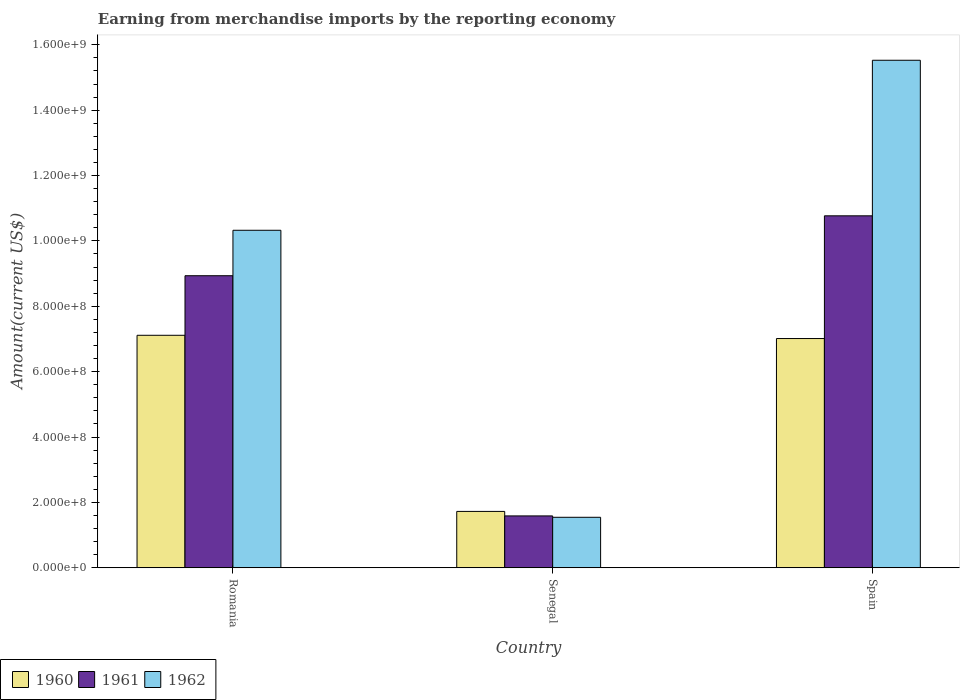How many bars are there on the 3rd tick from the left?
Your answer should be compact. 3. What is the label of the 2nd group of bars from the left?
Ensure brevity in your answer.  Senegal. In how many cases, is the number of bars for a given country not equal to the number of legend labels?
Provide a short and direct response. 0. What is the amount earned from merchandise imports in 1960 in Romania?
Your answer should be very brief. 7.11e+08. Across all countries, what is the maximum amount earned from merchandise imports in 1962?
Your answer should be compact. 1.55e+09. Across all countries, what is the minimum amount earned from merchandise imports in 1962?
Ensure brevity in your answer.  1.54e+08. In which country was the amount earned from merchandise imports in 1961 minimum?
Keep it short and to the point. Senegal. What is the total amount earned from merchandise imports in 1962 in the graph?
Provide a succinct answer. 2.74e+09. What is the difference between the amount earned from merchandise imports in 1962 in Romania and that in Spain?
Ensure brevity in your answer.  -5.20e+08. What is the difference between the amount earned from merchandise imports in 1962 in Senegal and the amount earned from merchandise imports in 1960 in Spain?
Your response must be concise. -5.47e+08. What is the average amount earned from merchandise imports in 1961 per country?
Offer a very short reply. 7.10e+08. What is the difference between the amount earned from merchandise imports of/in 1962 and amount earned from merchandise imports of/in 1960 in Spain?
Keep it short and to the point. 8.52e+08. What is the ratio of the amount earned from merchandise imports in 1960 in Senegal to that in Spain?
Make the answer very short. 0.25. Is the amount earned from merchandise imports in 1962 in Romania less than that in Spain?
Give a very brief answer. Yes. Is the difference between the amount earned from merchandise imports in 1962 in Senegal and Spain greater than the difference between the amount earned from merchandise imports in 1960 in Senegal and Spain?
Offer a terse response. No. What is the difference between the highest and the second highest amount earned from merchandise imports in 1962?
Your answer should be very brief. 1.40e+09. What is the difference between the highest and the lowest amount earned from merchandise imports in 1961?
Your answer should be compact. 9.18e+08. Is the sum of the amount earned from merchandise imports in 1961 in Senegal and Spain greater than the maximum amount earned from merchandise imports in 1960 across all countries?
Provide a succinct answer. Yes. What does the 1st bar from the left in Senegal represents?
Ensure brevity in your answer.  1960. Is it the case that in every country, the sum of the amount earned from merchandise imports in 1960 and amount earned from merchandise imports in 1962 is greater than the amount earned from merchandise imports in 1961?
Make the answer very short. Yes. How many bars are there?
Your response must be concise. 9. Are the values on the major ticks of Y-axis written in scientific E-notation?
Keep it short and to the point. Yes. Does the graph contain any zero values?
Your response must be concise. No. Where does the legend appear in the graph?
Your answer should be compact. Bottom left. How many legend labels are there?
Your answer should be compact. 3. How are the legend labels stacked?
Give a very brief answer. Horizontal. What is the title of the graph?
Offer a terse response. Earning from merchandise imports by the reporting economy. What is the label or title of the Y-axis?
Give a very brief answer. Amount(current US$). What is the Amount(current US$) of 1960 in Romania?
Provide a short and direct response. 7.11e+08. What is the Amount(current US$) in 1961 in Romania?
Offer a very short reply. 8.94e+08. What is the Amount(current US$) of 1962 in Romania?
Offer a terse response. 1.03e+09. What is the Amount(current US$) in 1960 in Senegal?
Your answer should be very brief. 1.72e+08. What is the Amount(current US$) of 1961 in Senegal?
Give a very brief answer. 1.59e+08. What is the Amount(current US$) in 1962 in Senegal?
Keep it short and to the point. 1.54e+08. What is the Amount(current US$) in 1960 in Spain?
Your answer should be compact. 7.01e+08. What is the Amount(current US$) of 1961 in Spain?
Make the answer very short. 1.08e+09. What is the Amount(current US$) in 1962 in Spain?
Offer a very short reply. 1.55e+09. Across all countries, what is the maximum Amount(current US$) of 1960?
Provide a succinct answer. 7.11e+08. Across all countries, what is the maximum Amount(current US$) of 1961?
Offer a very short reply. 1.08e+09. Across all countries, what is the maximum Amount(current US$) in 1962?
Keep it short and to the point. 1.55e+09. Across all countries, what is the minimum Amount(current US$) of 1960?
Keep it short and to the point. 1.72e+08. Across all countries, what is the minimum Amount(current US$) in 1961?
Keep it short and to the point. 1.59e+08. Across all countries, what is the minimum Amount(current US$) in 1962?
Give a very brief answer. 1.54e+08. What is the total Amount(current US$) in 1960 in the graph?
Your answer should be very brief. 1.58e+09. What is the total Amount(current US$) in 1961 in the graph?
Keep it short and to the point. 2.13e+09. What is the total Amount(current US$) of 1962 in the graph?
Keep it short and to the point. 2.74e+09. What is the difference between the Amount(current US$) of 1960 in Romania and that in Senegal?
Keep it short and to the point. 5.39e+08. What is the difference between the Amount(current US$) in 1961 in Romania and that in Senegal?
Make the answer very short. 7.35e+08. What is the difference between the Amount(current US$) in 1962 in Romania and that in Senegal?
Make the answer very short. 8.78e+08. What is the difference between the Amount(current US$) of 1960 in Romania and that in Spain?
Give a very brief answer. 9.99e+06. What is the difference between the Amount(current US$) in 1961 in Romania and that in Spain?
Your answer should be compact. -1.83e+08. What is the difference between the Amount(current US$) in 1962 in Romania and that in Spain?
Make the answer very short. -5.20e+08. What is the difference between the Amount(current US$) of 1960 in Senegal and that in Spain?
Your answer should be very brief. -5.29e+08. What is the difference between the Amount(current US$) in 1961 in Senegal and that in Spain?
Offer a very short reply. -9.18e+08. What is the difference between the Amount(current US$) in 1962 in Senegal and that in Spain?
Your answer should be compact. -1.40e+09. What is the difference between the Amount(current US$) of 1960 in Romania and the Amount(current US$) of 1961 in Senegal?
Make the answer very short. 5.53e+08. What is the difference between the Amount(current US$) of 1960 in Romania and the Amount(current US$) of 1962 in Senegal?
Keep it short and to the point. 5.57e+08. What is the difference between the Amount(current US$) of 1961 in Romania and the Amount(current US$) of 1962 in Senegal?
Provide a succinct answer. 7.39e+08. What is the difference between the Amount(current US$) in 1960 in Romania and the Amount(current US$) in 1961 in Spain?
Offer a terse response. -3.66e+08. What is the difference between the Amount(current US$) of 1960 in Romania and the Amount(current US$) of 1962 in Spain?
Provide a succinct answer. -8.42e+08. What is the difference between the Amount(current US$) in 1961 in Romania and the Amount(current US$) in 1962 in Spain?
Give a very brief answer. -6.59e+08. What is the difference between the Amount(current US$) of 1960 in Senegal and the Amount(current US$) of 1961 in Spain?
Ensure brevity in your answer.  -9.04e+08. What is the difference between the Amount(current US$) of 1960 in Senegal and the Amount(current US$) of 1962 in Spain?
Your answer should be compact. -1.38e+09. What is the difference between the Amount(current US$) of 1961 in Senegal and the Amount(current US$) of 1962 in Spain?
Keep it short and to the point. -1.39e+09. What is the average Amount(current US$) in 1960 per country?
Make the answer very short. 5.28e+08. What is the average Amount(current US$) in 1961 per country?
Provide a short and direct response. 7.10e+08. What is the average Amount(current US$) of 1962 per country?
Your answer should be compact. 9.13e+08. What is the difference between the Amount(current US$) in 1960 and Amount(current US$) in 1961 in Romania?
Offer a very short reply. -1.82e+08. What is the difference between the Amount(current US$) of 1960 and Amount(current US$) of 1962 in Romania?
Offer a terse response. -3.21e+08. What is the difference between the Amount(current US$) of 1961 and Amount(current US$) of 1962 in Romania?
Give a very brief answer. -1.39e+08. What is the difference between the Amount(current US$) in 1960 and Amount(current US$) in 1961 in Senegal?
Ensure brevity in your answer.  1.38e+07. What is the difference between the Amount(current US$) of 1960 and Amount(current US$) of 1962 in Senegal?
Your response must be concise. 1.80e+07. What is the difference between the Amount(current US$) in 1961 and Amount(current US$) in 1962 in Senegal?
Make the answer very short. 4.20e+06. What is the difference between the Amount(current US$) of 1960 and Amount(current US$) of 1961 in Spain?
Ensure brevity in your answer.  -3.76e+08. What is the difference between the Amount(current US$) of 1960 and Amount(current US$) of 1962 in Spain?
Keep it short and to the point. -8.52e+08. What is the difference between the Amount(current US$) in 1961 and Amount(current US$) in 1962 in Spain?
Offer a terse response. -4.76e+08. What is the ratio of the Amount(current US$) in 1960 in Romania to that in Senegal?
Provide a short and direct response. 4.13. What is the ratio of the Amount(current US$) in 1961 in Romania to that in Senegal?
Keep it short and to the point. 5.63. What is the ratio of the Amount(current US$) in 1962 in Romania to that in Senegal?
Give a very brief answer. 6.69. What is the ratio of the Amount(current US$) in 1960 in Romania to that in Spain?
Offer a terse response. 1.01. What is the ratio of the Amount(current US$) in 1961 in Romania to that in Spain?
Keep it short and to the point. 0.83. What is the ratio of the Amount(current US$) in 1962 in Romania to that in Spain?
Offer a terse response. 0.67. What is the ratio of the Amount(current US$) of 1960 in Senegal to that in Spain?
Offer a very short reply. 0.25. What is the ratio of the Amount(current US$) in 1961 in Senegal to that in Spain?
Offer a very short reply. 0.15. What is the ratio of the Amount(current US$) in 1962 in Senegal to that in Spain?
Ensure brevity in your answer.  0.1. What is the difference between the highest and the second highest Amount(current US$) in 1960?
Offer a terse response. 9.99e+06. What is the difference between the highest and the second highest Amount(current US$) of 1961?
Keep it short and to the point. 1.83e+08. What is the difference between the highest and the second highest Amount(current US$) of 1962?
Make the answer very short. 5.20e+08. What is the difference between the highest and the lowest Amount(current US$) in 1960?
Your response must be concise. 5.39e+08. What is the difference between the highest and the lowest Amount(current US$) in 1961?
Make the answer very short. 9.18e+08. What is the difference between the highest and the lowest Amount(current US$) of 1962?
Make the answer very short. 1.40e+09. 